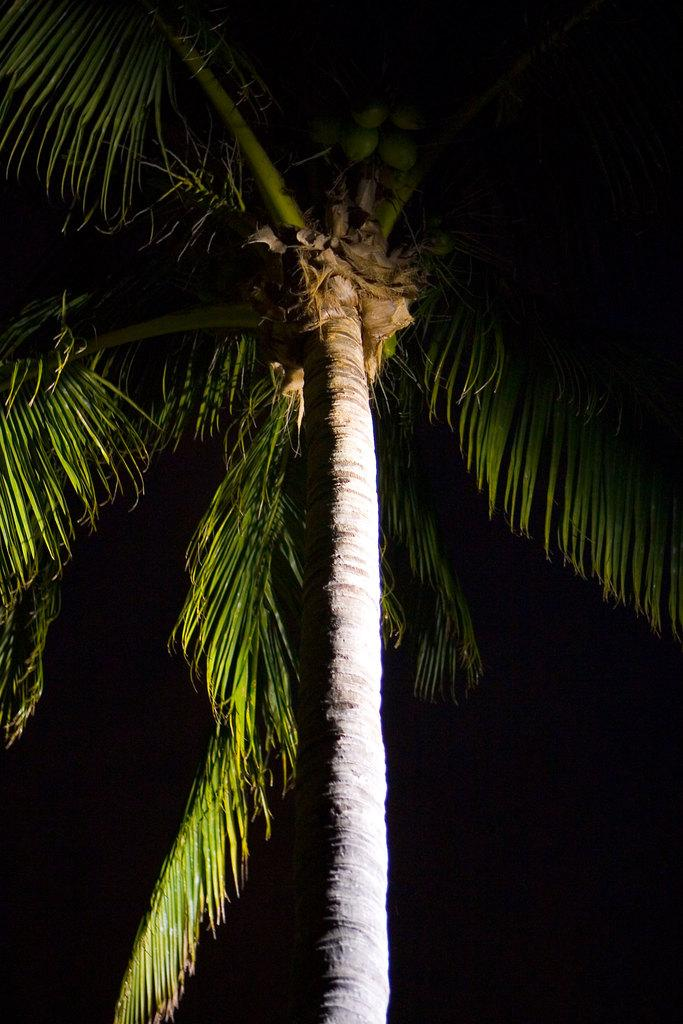What type of tree is in the image? There is a coconut tree in the image. What can be observed about the background of the image? The background of the image is dark. What type of humor does the father in the image use? There is no father present in the image, so it is not possible to determine the type of humor used. 